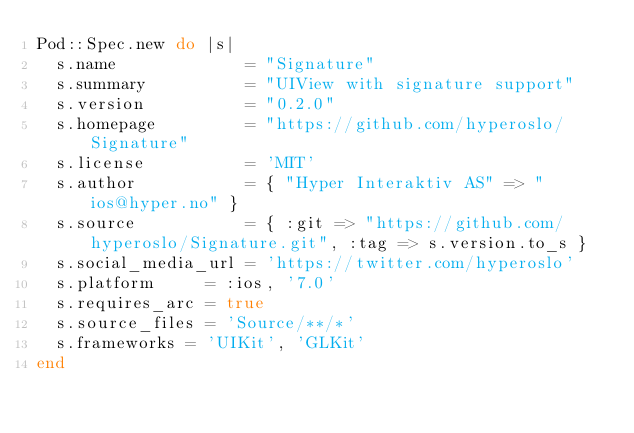<code> <loc_0><loc_0><loc_500><loc_500><_Ruby_>Pod::Spec.new do |s|
  s.name             = "Signature"
  s.summary          = "UIView with signature support"
  s.version          = "0.2.0"
  s.homepage         = "https://github.com/hyperoslo/Signature"
  s.license          = 'MIT'
  s.author           = { "Hyper Interaktiv AS" => "ios@hyper.no" }
  s.source           = { :git => "https://github.com/hyperoslo/Signature.git", :tag => s.version.to_s }
  s.social_media_url = 'https://twitter.com/hyperoslo'
  s.platform     = :ios, '7.0'
  s.requires_arc = true
  s.source_files = 'Source/**/*'
  s.frameworks = 'UIKit', 'GLKit'
end
</code> 